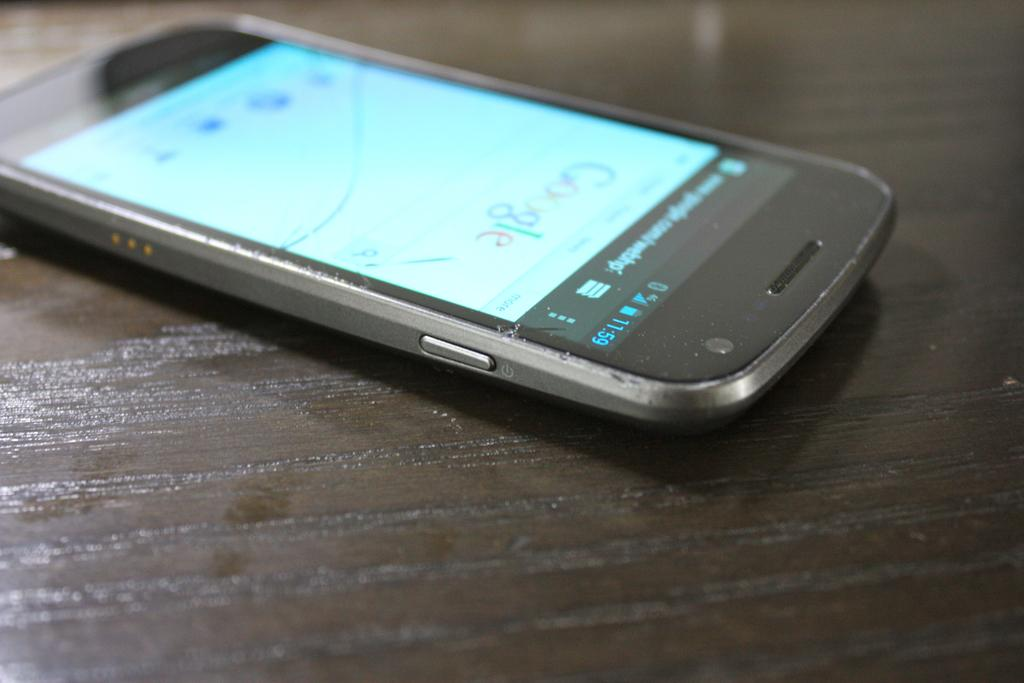<image>
Share a concise interpretation of the image provided. A cell phone with a google search application open lying on a desk 